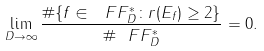<formula> <loc_0><loc_0><loc_500><loc_500>\lim _ { D \rightarrow \infty } \frac { \# \{ f \in \ F F _ { D } ^ { * } \colon r ( E _ { f } ) \geq 2 \} } { \# \ F F _ { D } ^ { * } } = 0 .</formula> 